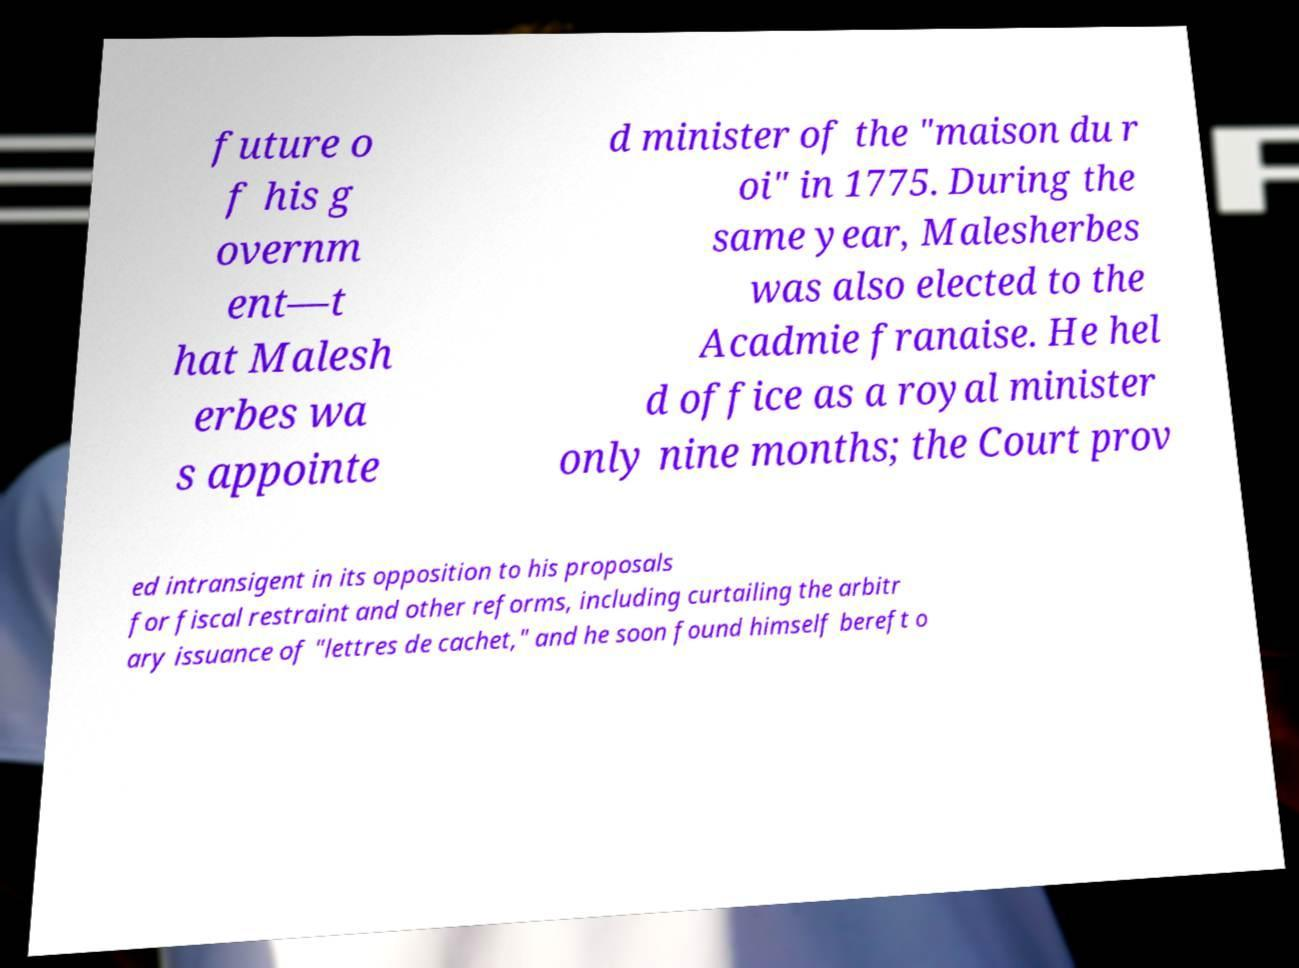Please identify and transcribe the text found in this image. future o f his g overnm ent—t hat Malesh erbes wa s appointe d minister of the "maison du r oi" in 1775. During the same year, Malesherbes was also elected to the Acadmie franaise. He hel d office as a royal minister only nine months; the Court prov ed intransigent in its opposition to his proposals for fiscal restraint and other reforms, including curtailing the arbitr ary issuance of "lettres de cachet," and he soon found himself bereft o 